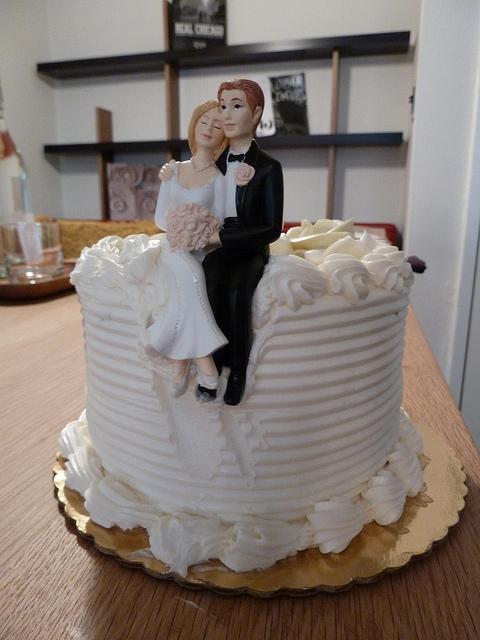How many tiers does this cake have?
Give a very brief answer. 1. How many tiers are there?
Give a very brief answer. 1. How many books are visible?
Give a very brief answer. 2. How many people are on the ski lift?
Give a very brief answer. 0. 